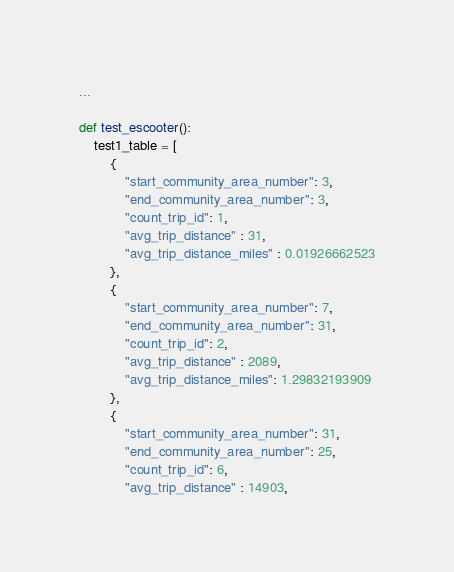Convert code to text. <code><loc_0><loc_0><loc_500><loc_500><_Python_>
...

def test_escooter():
    test1_table = [
        {
            "start_community_area_number": 3,
            "end_community_area_number": 3,
            "count_trip_id": 1,
            "avg_trip_distance" : 31,
            "avg_trip_distance_miles" : 0.01926662523
        },
        {
            "start_community_area_number": 7,
            "end_community_area_number": 31,
            "count_trip_id": 2,
            "avg_trip_distance" : 2089,
            "avg_trip_distance_miles": 1.29832193909
        },
        {
            "start_community_area_number": 31,
            "end_community_area_number": 25,
            "count_trip_id": 6,
            "avg_trip_distance" : 14903,</code> 